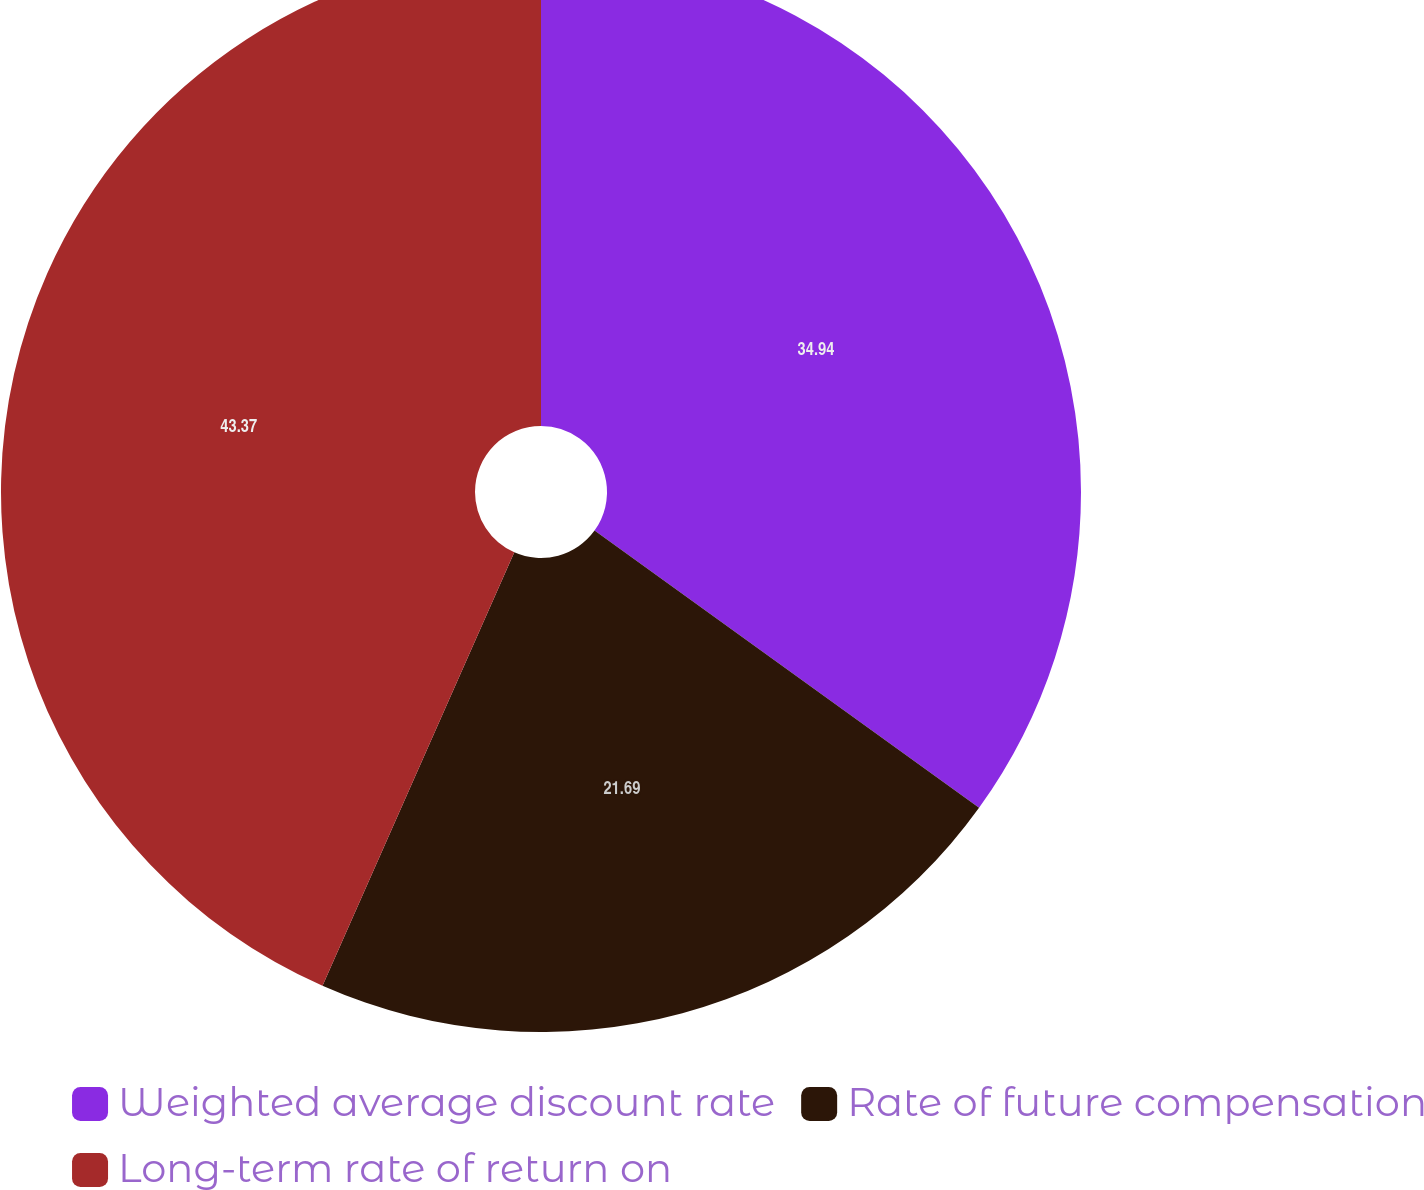Convert chart to OTSL. <chart><loc_0><loc_0><loc_500><loc_500><pie_chart><fcel>Weighted average discount rate<fcel>Rate of future compensation<fcel>Long-term rate of return on<nl><fcel>34.94%<fcel>21.69%<fcel>43.37%<nl></chart> 